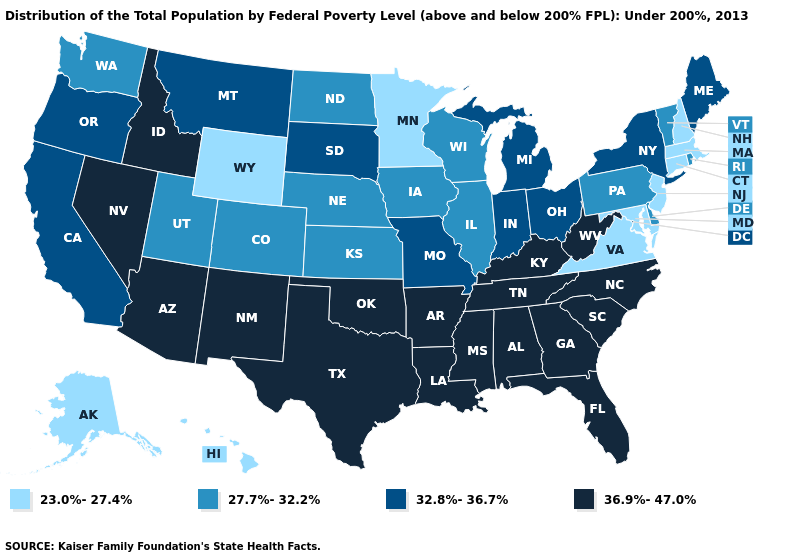Name the states that have a value in the range 36.9%-47.0%?
Concise answer only. Alabama, Arizona, Arkansas, Florida, Georgia, Idaho, Kentucky, Louisiana, Mississippi, Nevada, New Mexico, North Carolina, Oklahoma, South Carolina, Tennessee, Texas, West Virginia. Name the states that have a value in the range 27.7%-32.2%?
Give a very brief answer. Colorado, Delaware, Illinois, Iowa, Kansas, Nebraska, North Dakota, Pennsylvania, Rhode Island, Utah, Vermont, Washington, Wisconsin. What is the value of Minnesota?
Quick response, please. 23.0%-27.4%. Does Mississippi have the lowest value in the USA?
Keep it brief. No. Does Texas have the highest value in the South?
Be succinct. Yes. What is the value of Massachusetts?
Keep it brief. 23.0%-27.4%. What is the lowest value in the Northeast?
Short answer required. 23.0%-27.4%. Does the map have missing data?
Keep it brief. No. Among the states that border Pennsylvania , does New York have the highest value?
Write a very short answer. No. Does Rhode Island have a higher value than Wisconsin?
Be succinct. No. How many symbols are there in the legend?
Keep it brief. 4. What is the highest value in the USA?
Concise answer only. 36.9%-47.0%. What is the highest value in states that border Delaware?
Keep it brief. 27.7%-32.2%. Among the states that border Michigan , does Indiana have the lowest value?
Be succinct. No. How many symbols are there in the legend?
Be succinct. 4. 